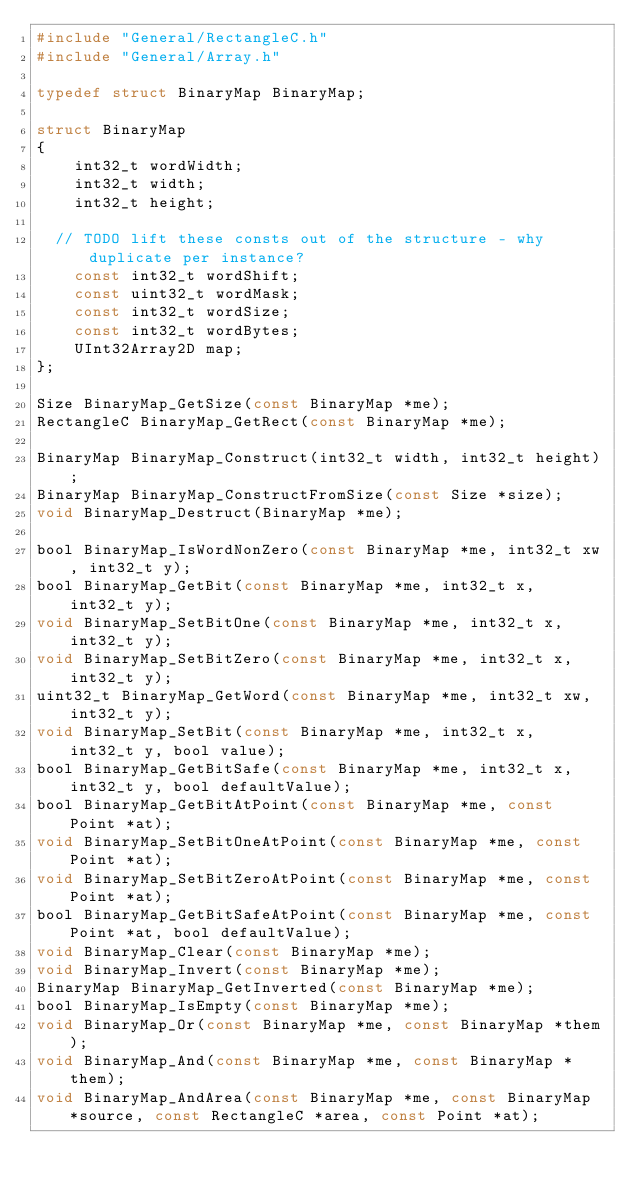Convert code to text. <code><loc_0><loc_0><loc_500><loc_500><_C_>#include "General/RectangleC.h"
#include "General/Array.h"

typedef struct BinaryMap BinaryMap;

struct BinaryMap
{
    int32_t wordWidth;
    int32_t width;
    int32_t height;

  // TODO lift these consts out of the structure - why duplicate per instance?
    const int32_t wordShift;
    const uint32_t wordMask;
    const int32_t wordSize;
    const int32_t wordBytes;
    UInt32Array2D map;
};

Size BinaryMap_GetSize(const BinaryMap *me);
RectangleC BinaryMap_GetRect(const BinaryMap *me);

BinaryMap BinaryMap_Construct(int32_t width, int32_t height);
BinaryMap BinaryMap_ConstructFromSize(const Size *size);
void BinaryMap_Destruct(BinaryMap *me);

bool BinaryMap_IsWordNonZero(const BinaryMap *me, int32_t xw, int32_t y);
bool BinaryMap_GetBit(const BinaryMap *me, int32_t x, int32_t y);
void BinaryMap_SetBitOne(const BinaryMap *me, int32_t x, int32_t y);
void BinaryMap_SetBitZero(const BinaryMap *me, int32_t x, int32_t y);
uint32_t BinaryMap_GetWord(const BinaryMap *me, int32_t xw, int32_t y);
void BinaryMap_SetBit(const BinaryMap *me, int32_t x, int32_t y, bool value);
bool BinaryMap_GetBitSafe(const BinaryMap *me, int32_t x, int32_t y, bool defaultValue);
bool BinaryMap_GetBitAtPoint(const BinaryMap *me, const Point *at);
void BinaryMap_SetBitOneAtPoint(const BinaryMap *me, const Point *at);
void BinaryMap_SetBitZeroAtPoint(const BinaryMap *me, const Point *at);
bool BinaryMap_GetBitSafeAtPoint(const BinaryMap *me, const Point *at, bool defaultValue);
void BinaryMap_Clear(const BinaryMap *me);
void BinaryMap_Invert(const BinaryMap *me);
BinaryMap BinaryMap_GetInverted(const BinaryMap *me);
bool BinaryMap_IsEmpty(const BinaryMap *me);
void BinaryMap_Or(const BinaryMap *me, const BinaryMap *them);
void BinaryMap_And(const BinaryMap *me, const BinaryMap *them);
void BinaryMap_AndArea(const BinaryMap *me, const BinaryMap *source, const RectangleC *area, const Point *at);</code> 